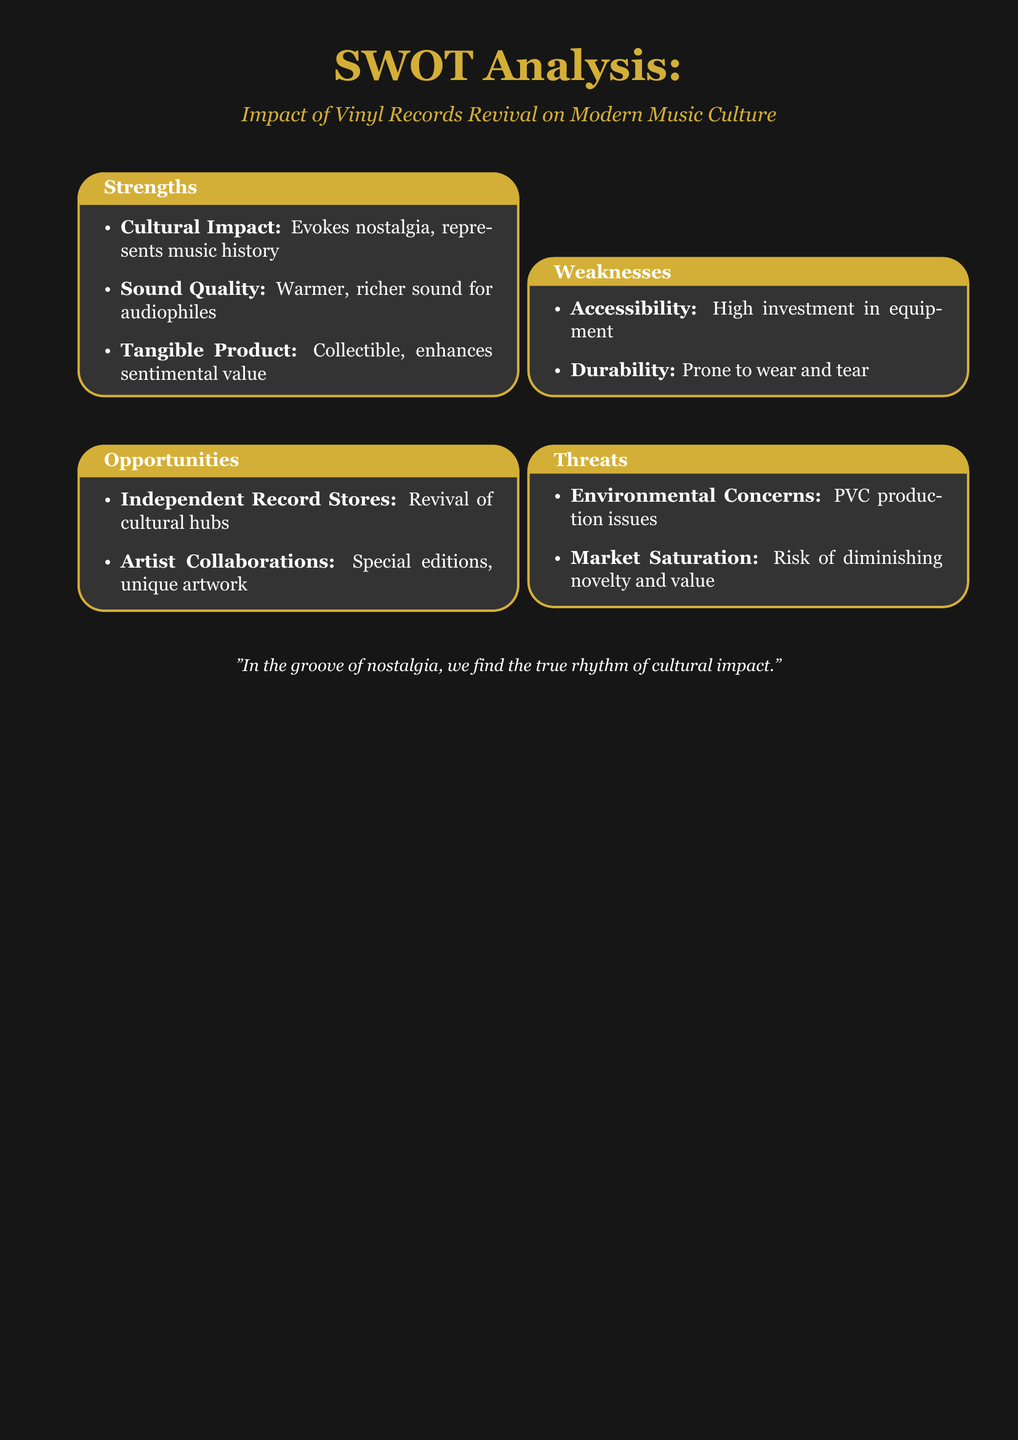What are the strengths related to the cultural aspect? The strengths include cultural impact and evokes nostalgia.
Answer: Cultural Impact How many weaknesses are listed in the document? The document lists two weaknesses under the SWOT analysis.
Answer: Two What is a significant opportunity mentioned for independent record stores? The document states that independent record stores are a revival of cultural hubs.
Answer: Revival of cultural hubs What sound quality characteristic is mentioned for vinyl records? The document describes the sound quality of vinyl records as warmer and richer.
Answer: Warmer, richer sound What is a major environmental concern listed? The document highlights PV production as an environmental concern associated with vinyl records.
Answer: PVC production issues What type of product do vinyl records represent according to the strengths? Vinyl records are described as a tangible product.
Answer: Tangible product What is a potential threat listed concerning market trends? The document mentions market saturation as a risk in the context of vinyl records.
Answer: Market saturation What sentimental aspect of vinyl records is emphasized? The document states that vinyl records enhance sentimental value.
Answer: Enhances sentimental value What does the document suggest about artist collaborations? The document suggests that artist collaborations can lead to special editions and unique artwork.
Answer: Special editions, unique artwork 